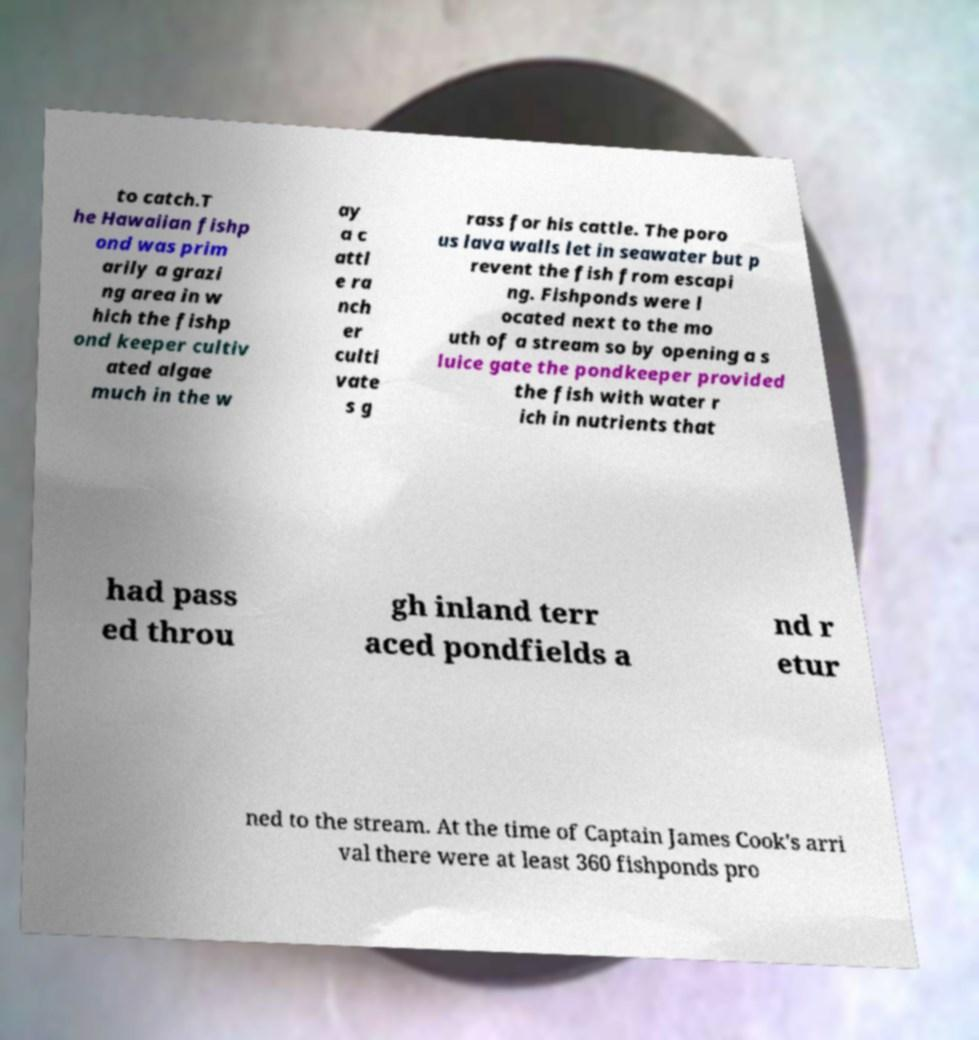Please read and relay the text visible in this image. What does it say? to catch.T he Hawaiian fishp ond was prim arily a grazi ng area in w hich the fishp ond keeper cultiv ated algae much in the w ay a c attl e ra nch er culti vate s g rass for his cattle. The poro us lava walls let in seawater but p revent the fish from escapi ng. Fishponds were l ocated next to the mo uth of a stream so by opening a s luice gate the pondkeeper provided the fish with water r ich in nutrients that had pass ed throu gh inland terr aced pondfields a nd r etur ned to the stream. At the time of Captain James Cook's arri val there were at least 360 fishponds pro 